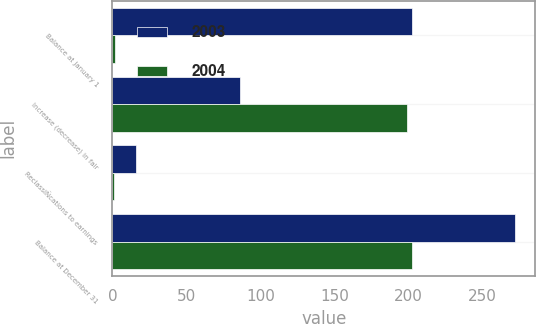Convert chart. <chart><loc_0><loc_0><loc_500><loc_500><stacked_bar_chart><ecel><fcel>Balance at January 1<fcel>Increase (decrease) in fair<fcel>ReclassiÑcations to earnings<fcel>Balance at December 31<nl><fcel>2003<fcel>202<fcel>86<fcel>16<fcel>272<nl><fcel>2004<fcel>2<fcel>199<fcel>1<fcel>202<nl></chart> 